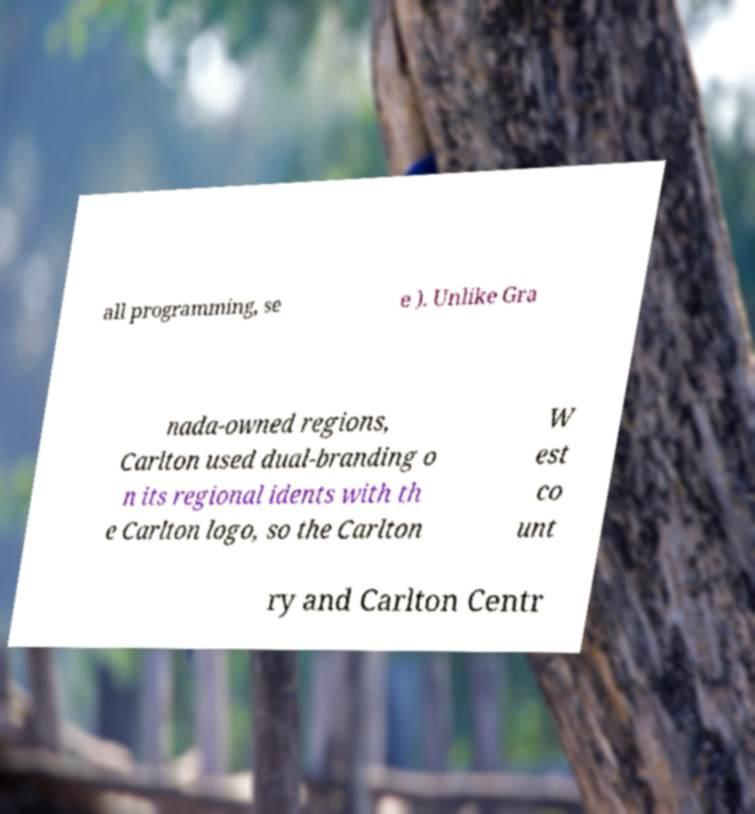Could you extract and type out the text from this image? all programming, se e ). Unlike Gra nada-owned regions, Carlton used dual-branding o n its regional idents with th e Carlton logo, so the Carlton W est co unt ry and Carlton Centr 